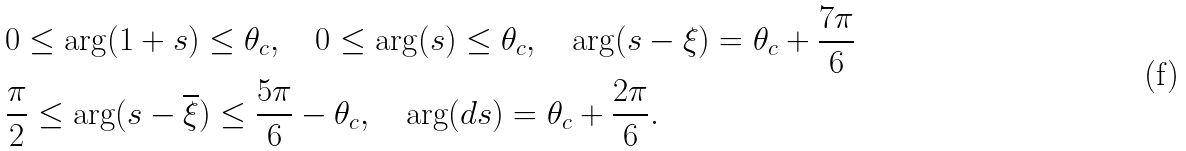<formula> <loc_0><loc_0><loc_500><loc_500>& 0 \leq \arg ( 1 + s ) \leq \theta _ { c } , \quad 0 \leq \arg ( s ) \leq \theta _ { c } , \quad \arg ( s - \xi ) = \theta _ { c } + \frac { 7 \pi } 6 \\ & \frac { \pi } 2 \leq \arg ( s - \overline { \xi } ) \leq \frac { 5 \pi } 6 - \theta _ { c } , \quad \arg ( d s ) = \theta _ { c } + \frac { 2 \pi } 6 .</formula> 